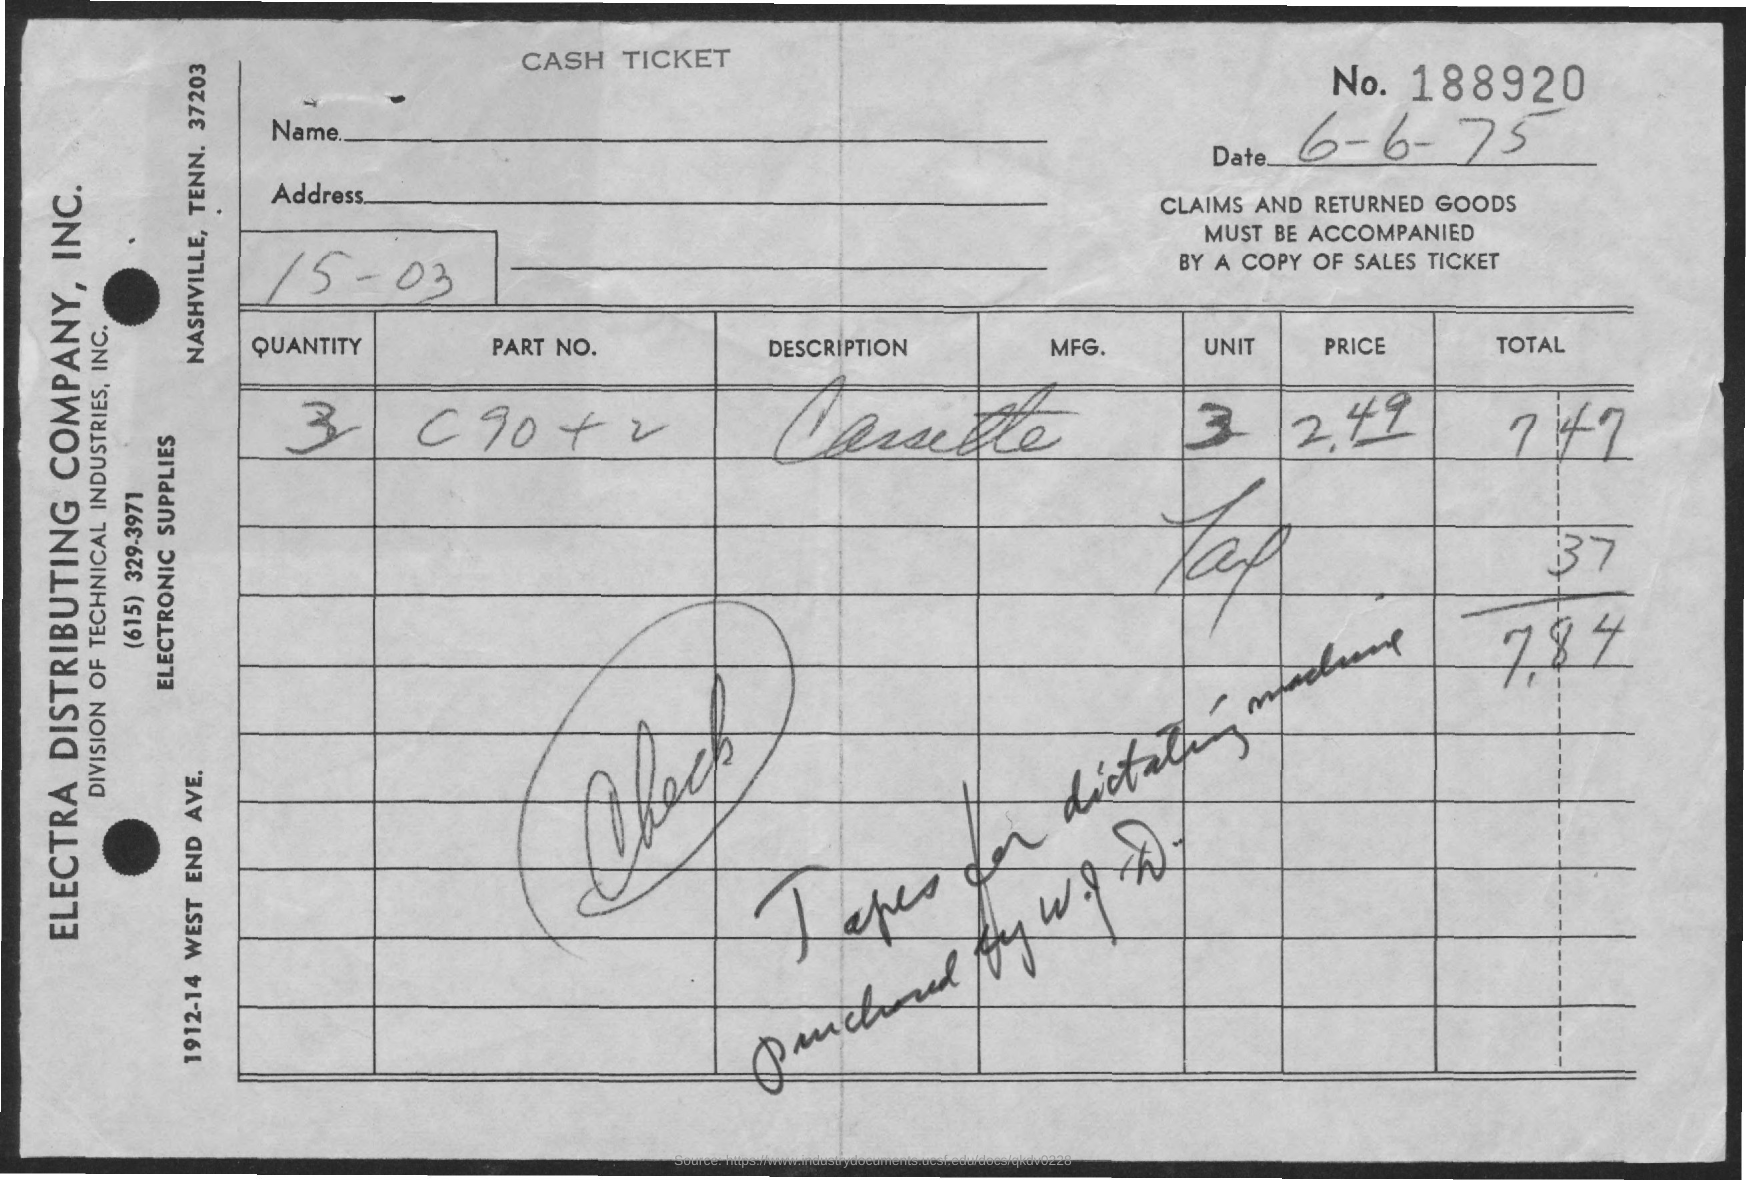What is the date on the document?
Offer a very short reply. 6-6-75. What is the Quantity?
Keep it short and to the point. 3. What is the price?
Make the answer very short. 2.49. What is the Tax?
Your answer should be very brief. 37. What is the Total amount?
Your response must be concise. 7.84. 